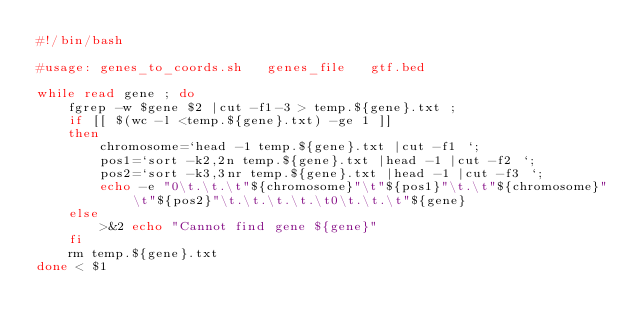Convert code to text. <code><loc_0><loc_0><loc_500><loc_500><_Bash_>#!/bin/bash

#usage: genes_to_coords.sh   genes_file   gtf.bed

while read gene ; do 
	fgrep -w $gene $2 |cut -f1-3 > temp.${gene}.txt ; 
	if [[ $(wc -l <temp.${gene}.txt) -ge 1 ]] 
	then
		chromosome=`head -1 temp.${gene}.txt |cut -f1 `;
		pos1=`sort -k2,2n temp.${gene}.txt |head -1 |cut -f2 `; 
		pos2=`sort -k3,3nr temp.${gene}.txt |head -1 |cut -f3 `; 
		echo -e "0\t.\t.\t"${chromosome}"\t"${pos1}"\t.\t"${chromosome}"\t"${pos2}"\t.\t.\t.\t.\t0\t.\t.\t"${gene}
	else
		>&2 echo "Cannot find gene ${gene}"
	fi
	rm temp.${gene}.txt
done < $1
</code> 